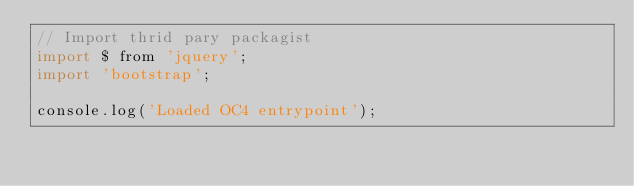<code> <loc_0><loc_0><loc_500><loc_500><_JavaScript_>// Import thrid pary packagist
import $ from 'jquery';
import 'bootstrap';

console.log('Loaded OC4 entrypoint');
</code> 